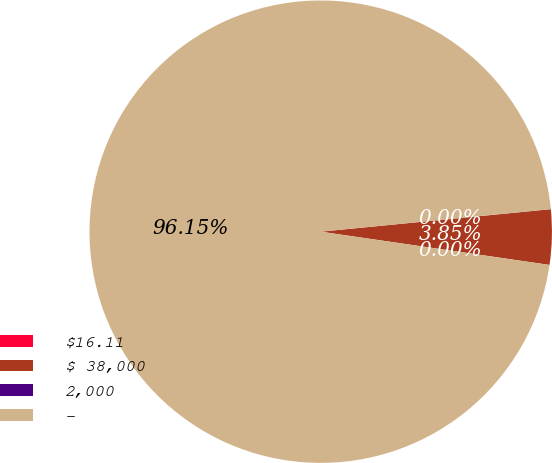<chart> <loc_0><loc_0><loc_500><loc_500><pie_chart><fcel>$16.11<fcel>$ 38,000<fcel>2,000<fcel>-<nl><fcel>0.0%<fcel>3.85%<fcel>0.0%<fcel>96.15%<nl></chart> 